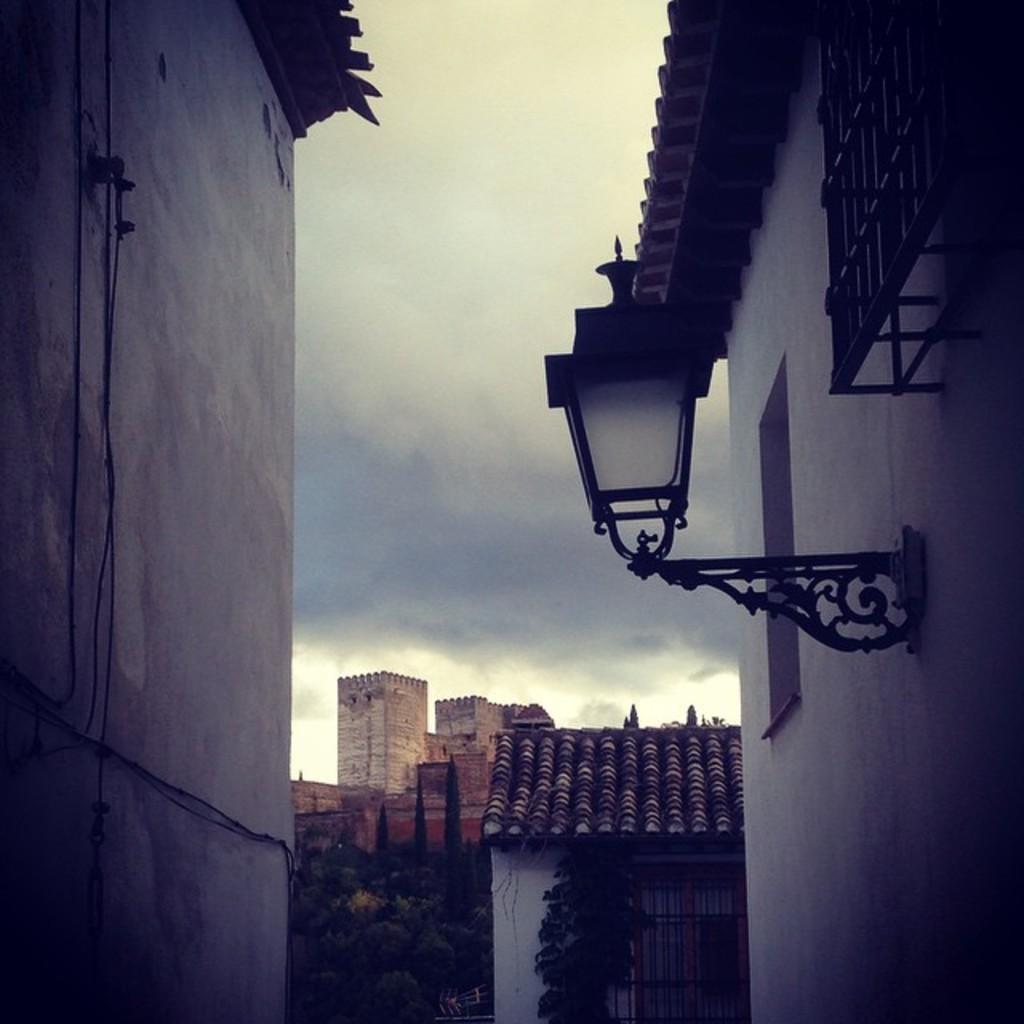Could you give a brief overview of what you see in this image? In the background of the image we can see buildings,trees. To the both sides of the image there are walls of a building. At the top of the image there is sky. 